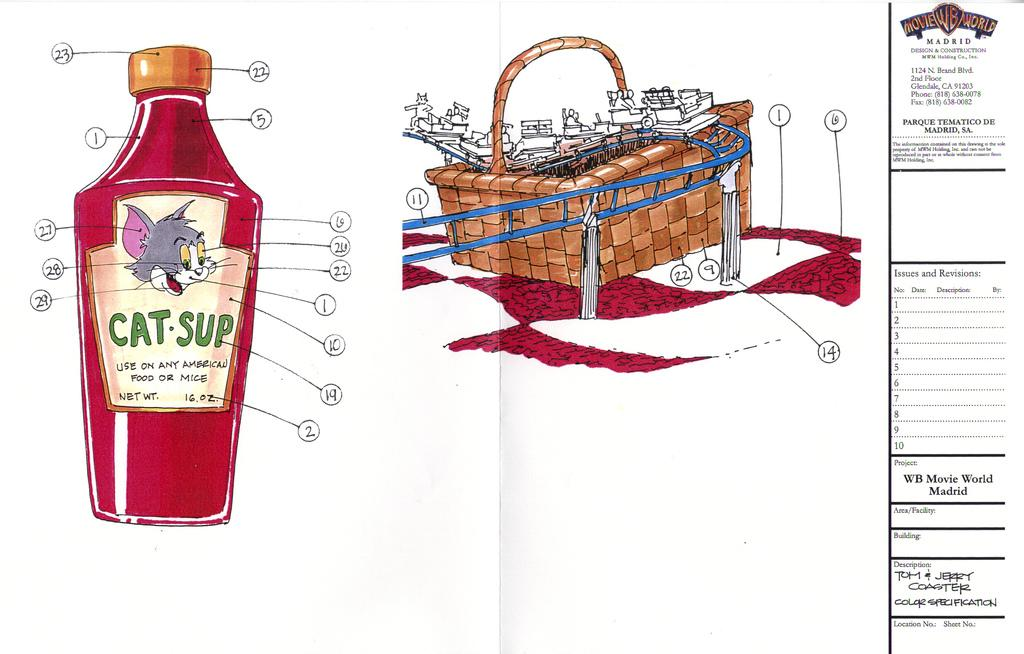<image>
Share a concise interpretation of the image provided. A cartoon of a condiment bottle says "Cat-Sup" on it and has a cartoon cat drawn on it 